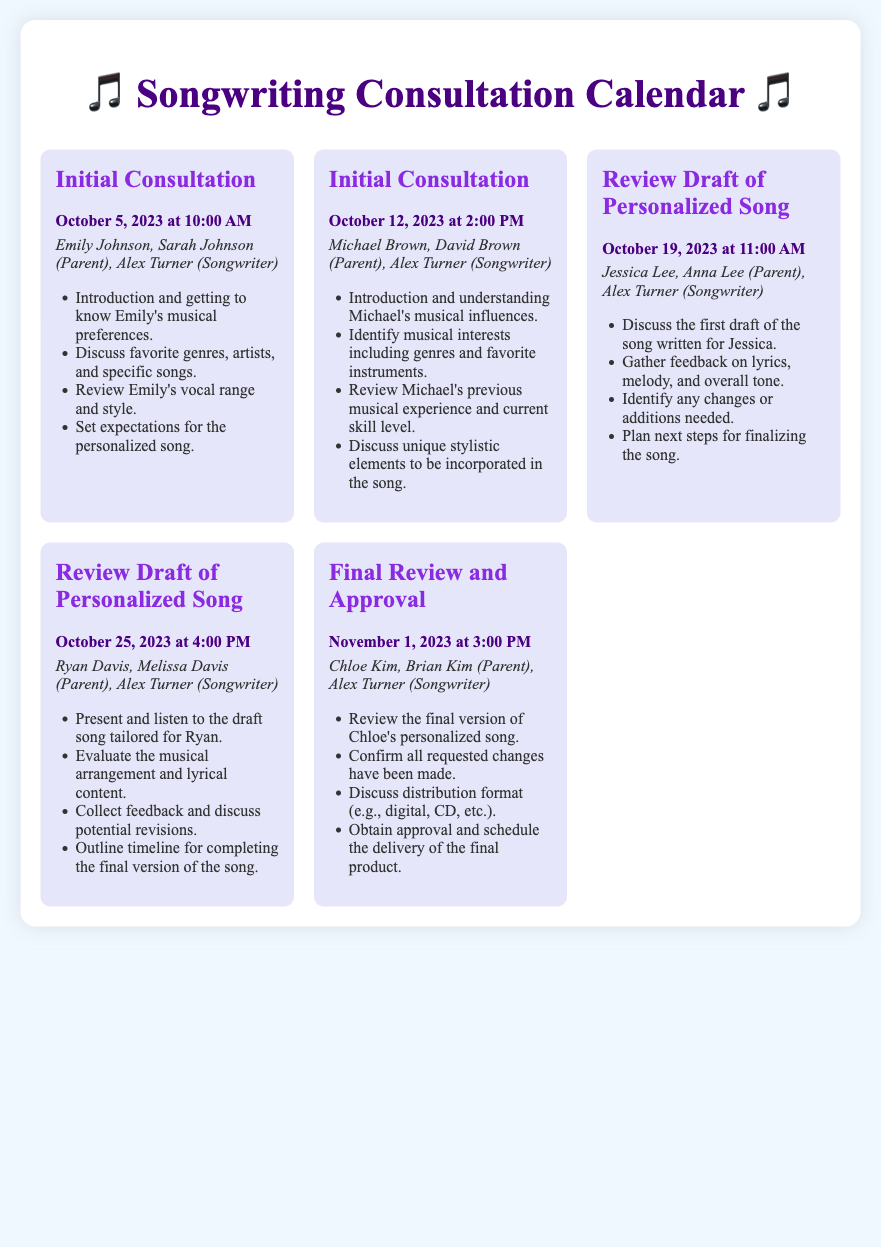What is the date and time of the Initial Consultation for Emily Johnson? The Initial Consultation for Emily Johnson is scheduled for October 5, 2023, at 10:00 AM.
Answer: October 5, 2023 at 10:00 AM Who is the parent attending the consultation with Michael Brown? The parent attending the consultation with Michael Brown is David Brown.
Answer: David Brown How many Review Draft of Personalized Song meetings are scheduled? There are two Review Draft of Personalized Song meetings scheduled.
Answer: Two What is the main focus of the Final Review and Approval meeting? The main focus of the Final Review and Approval meeting is to review the final version of Chloe's personalized song.
Answer: Review final version What specific feedback is gathered during the Review Draft of Personalized Song for Jessica Lee? Feedback gathered includes lyrics, melody, and overall tone.
Answer: Lyrics, melody, overall tone Who is the songwriter for all the consultations and reviews listed? The songwriter for all consultations and reviews is Alex Turner.
Answer: Alex Turner What type of document is this? This document is a Songwriting Consultation Calendar.
Answer: Songwriting Consultation Calendar 